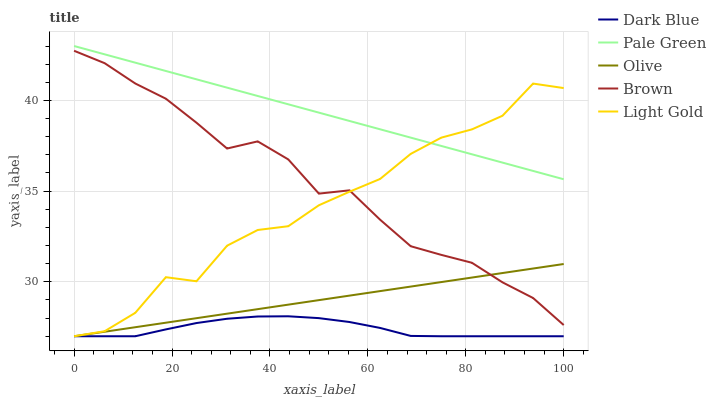Does Dark Blue have the minimum area under the curve?
Answer yes or no. Yes. Does Pale Green have the maximum area under the curve?
Answer yes or no. Yes. Does Pale Green have the minimum area under the curve?
Answer yes or no. No. Does Dark Blue have the maximum area under the curve?
Answer yes or no. No. Is Olive the smoothest?
Answer yes or no. Yes. Is Light Gold the roughest?
Answer yes or no. Yes. Is Dark Blue the smoothest?
Answer yes or no. No. Is Dark Blue the roughest?
Answer yes or no. No. Does Olive have the lowest value?
Answer yes or no. Yes. Does Pale Green have the lowest value?
Answer yes or no. No. Does Pale Green have the highest value?
Answer yes or no. Yes. Does Dark Blue have the highest value?
Answer yes or no. No. Is Brown less than Pale Green?
Answer yes or no. Yes. Is Pale Green greater than Dark Blue?
Answer yes or no. Yes. Does Pale Green intersect Light Gold?
Answer yes or no. Yes. Is Pale Green less than Light Gold?
Answer yes or no. No. Is Pale Green greater than Light Gold?
Answer yes or no. No. Does Brown intersect Pale Green?
Answer yes or no. No. 